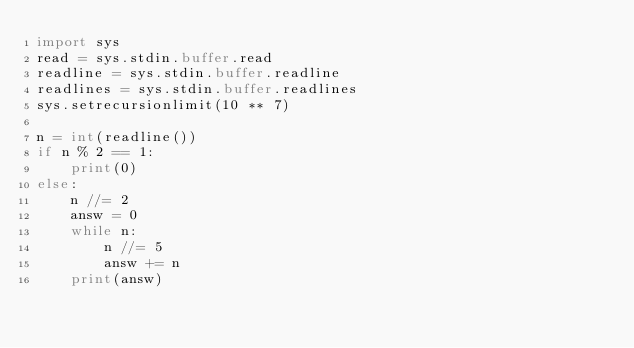Convert code to text. <code><loc_0><loc_0><loc_500><loc_500><_Python_>import sys
read = sys.stdin.buffer.read
readline = sys.stdin.buffer.readline
readlines = sys.stdin.buffer.readlines
sys.setrecursionlimit(10 ** 7)
 
n = int(readline())
if n % 2 == 1:
    print(0)
else:
    n //= 2
    answ = 0
    while n:
        n //= 5
        answ += n
    print(answ)</code> 